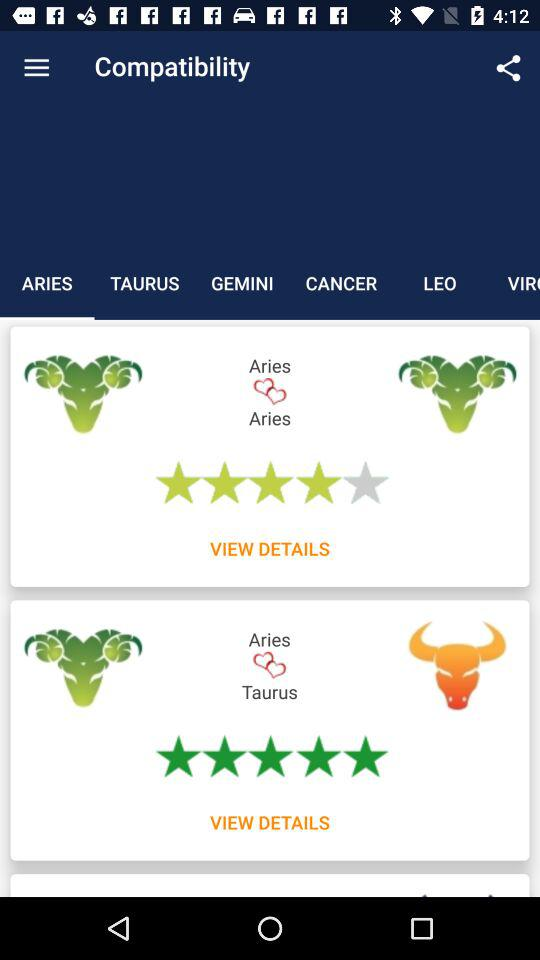Which sign has a higher compatibility score, Aries or Taurus?
Answer the question using a single word or phrase. Taurus 